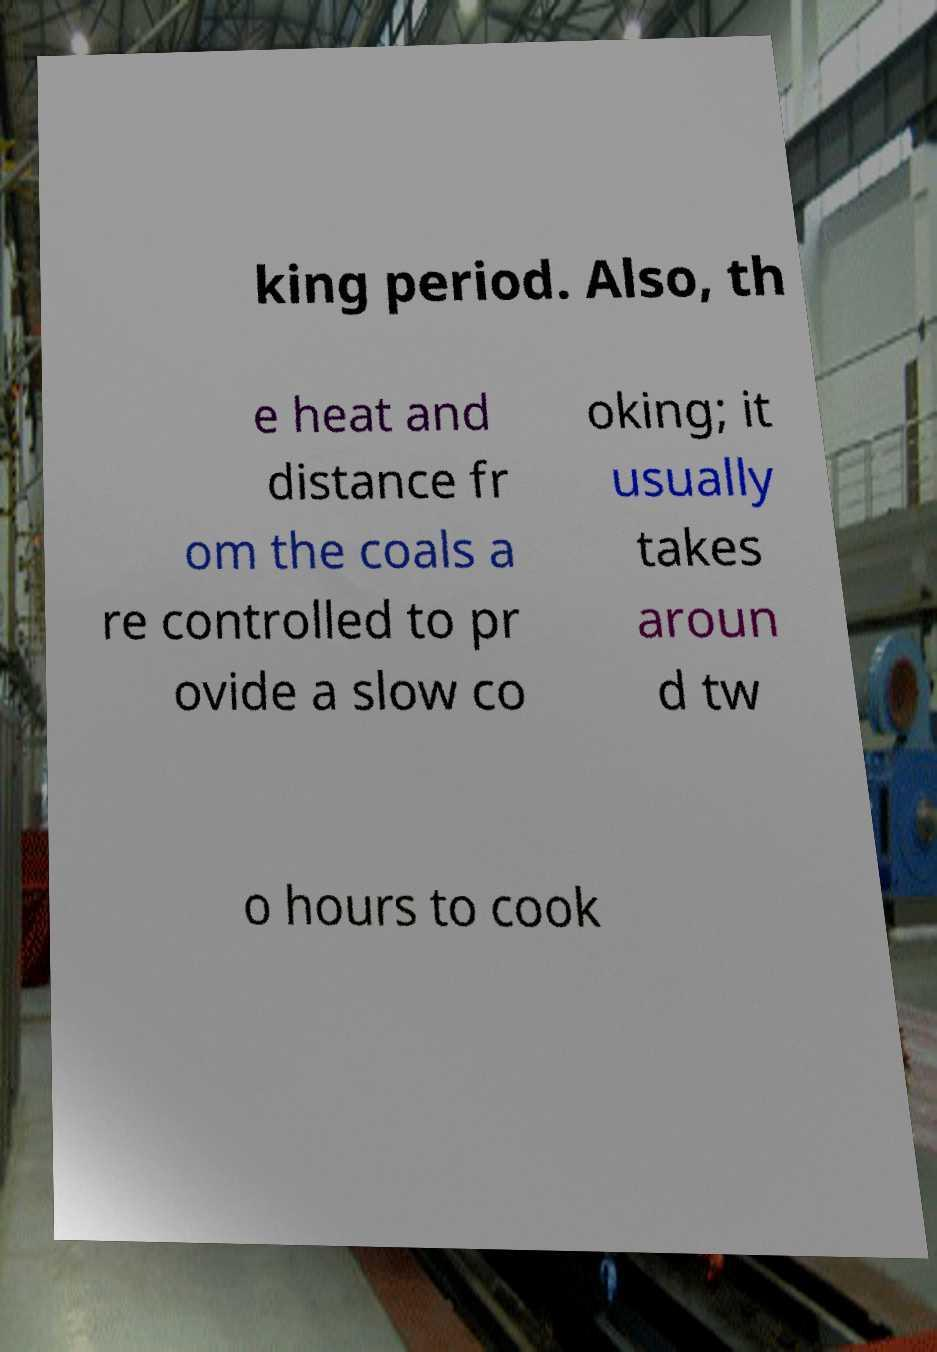Can you read and provide the text displayed in the image?This photo seems to have some interesting text. Can you extract and type it out for me? king period. Also, th e heat and distance fr om the coals a re controlled to pr ovide a slow co oking; it usually takes aroun d tw o hours to cook 